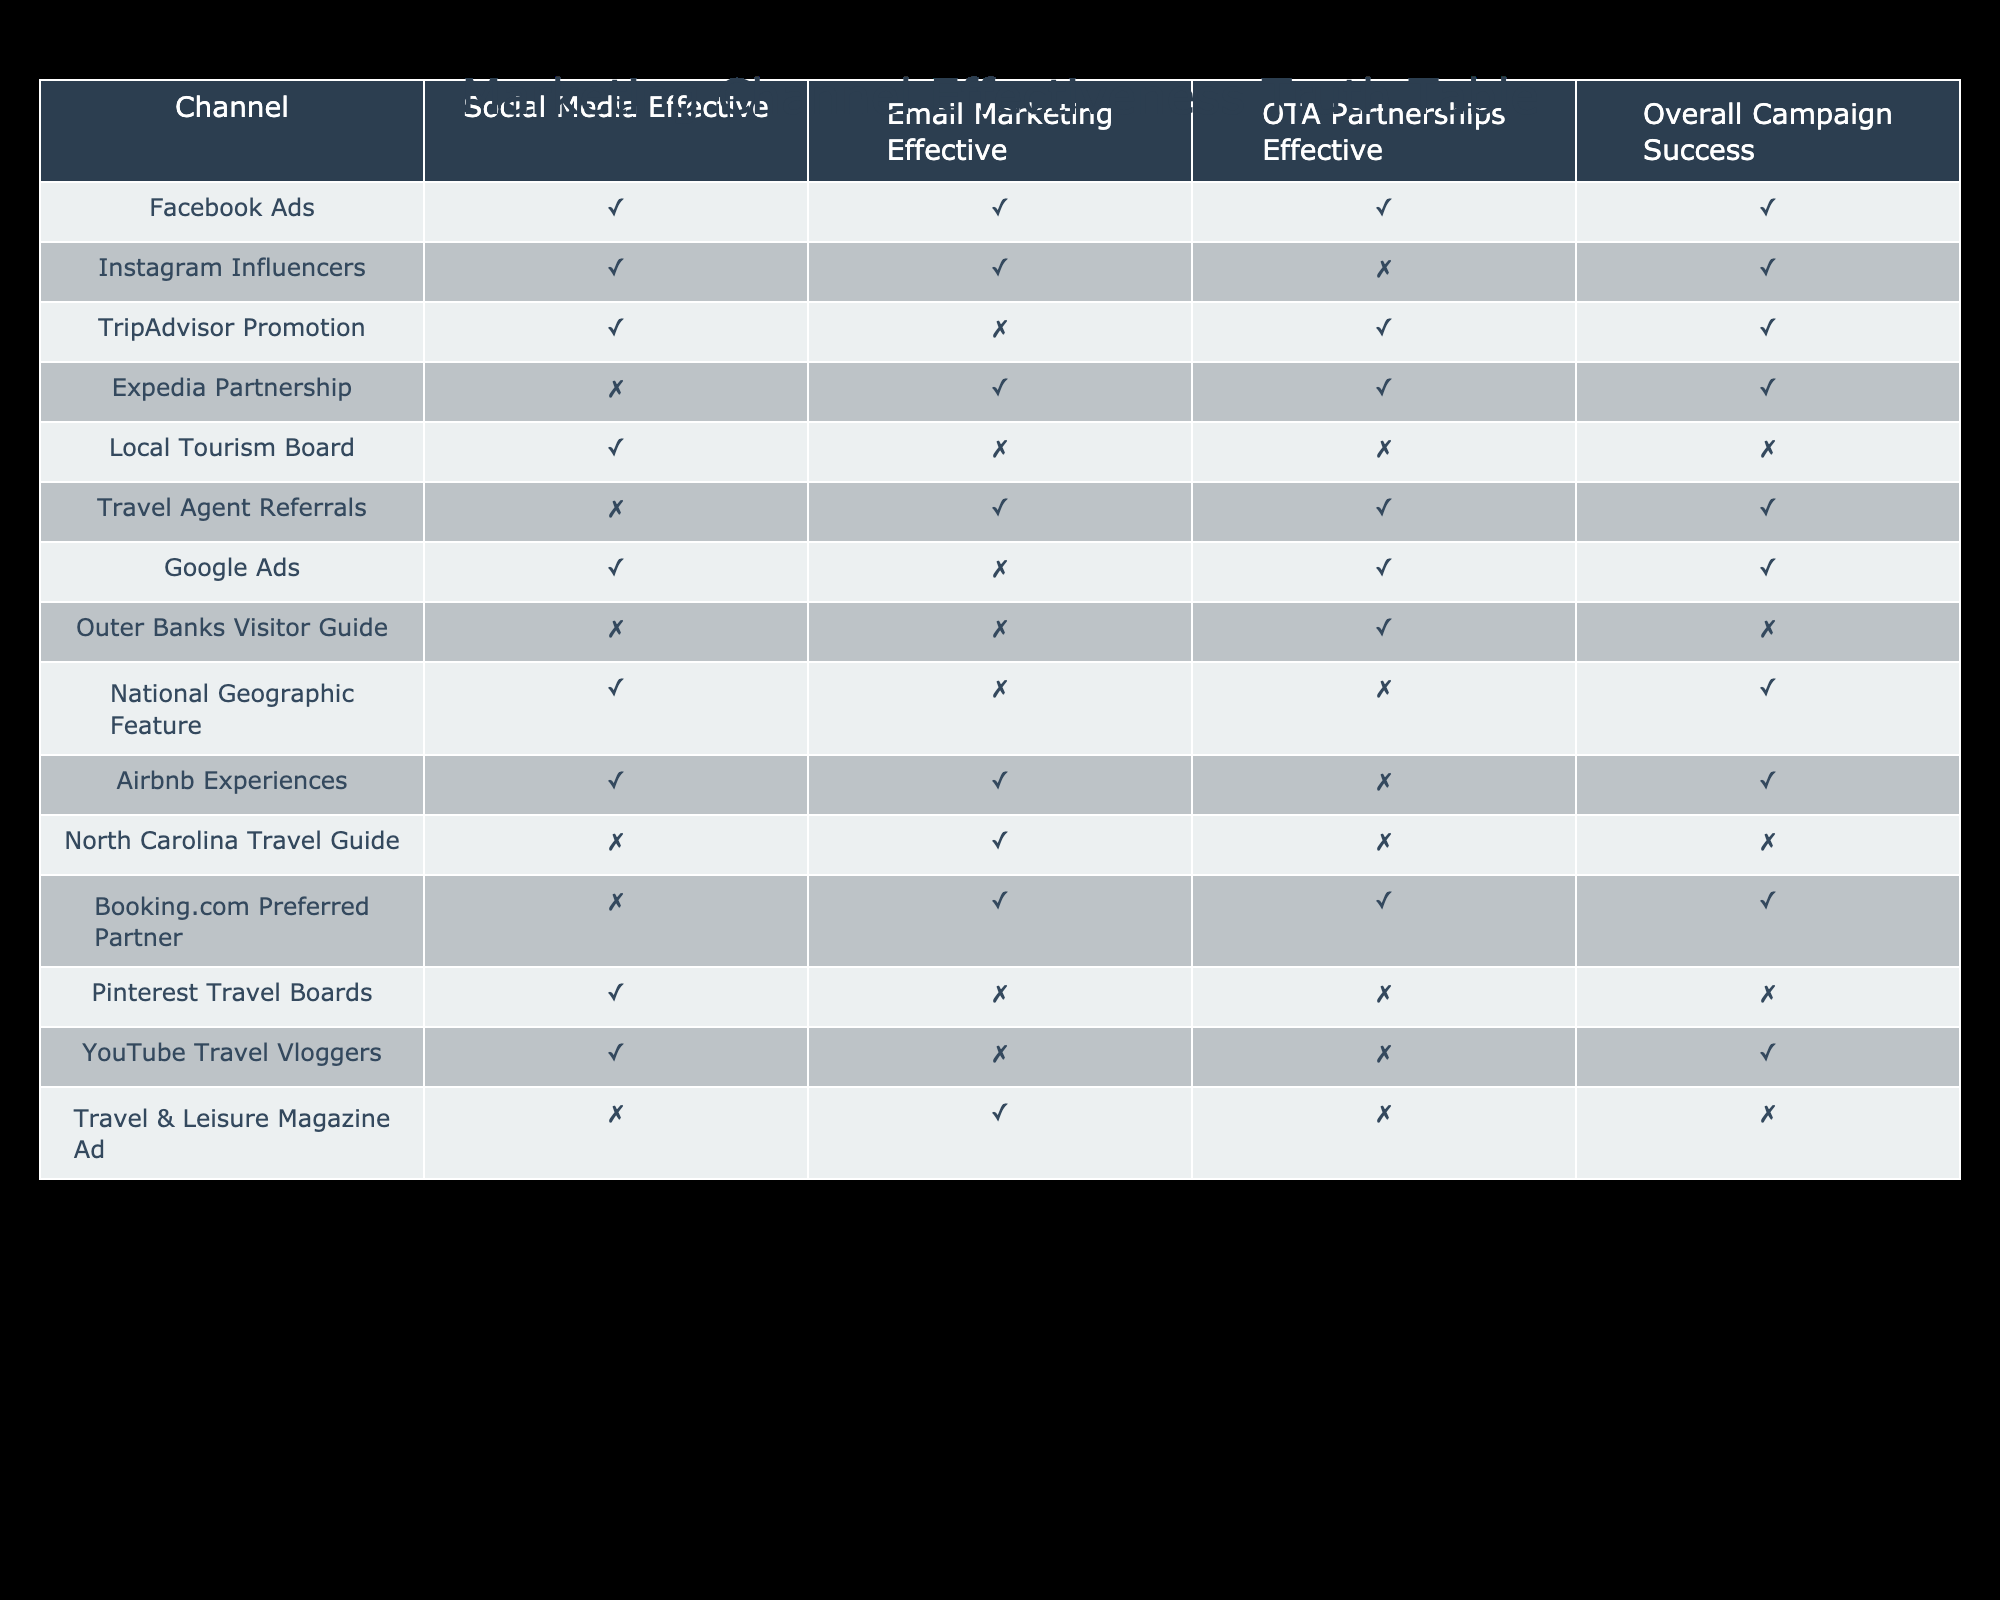What marketing channels were effective for the "TripAdvisor Promotion"? The table indicates that "TripAdvisor Promotion" was effective on "Social Media" and "OTA Partnerships," as both are marked TRUE. Therefore, the effective channels are those two.
Answer: Social Media, OTA Partnerships How many marketing channels are effective for "Email Marketing"? By reviewing the table, it's evident that the following channels are effective for Email Marketing: Instagram Influencers, Expedia Partnership, Travel Agent Referrals, and Booking.com Preferred Partner. There are four channels with TRUE for Email Marketing effectiveness.
Answer: 4 Is there a marketing channel that is effective for "Social Media" but not for "OTA Partnerships"? Looking at the table, "Local Tourism Board" is effective on Social Media (TRUE) and has no effectiveness on OTA Partnerships (FALSE). Therefore, it fits the criteria of being effective for Social Media but ineffective for OTA Partnerships.
Answer: Yes What is the overall success rate of campaigns that utilized both "Email Marketing" and "OTA Partnerships"? From the table, we identify the channels that were effective in both Email Marketing and OTA Partnerships: Expedia Partnership, Travel Agent Referrals, and Booking.com Preferred Partner. In total, there are three channels where both criteria are fulfilled, and all three channels also have an overall campaign success of TRUE. This results in a successful rate of 100% for these channels.
Answer: 100% Which marketing channels have "Social Media Effective" as TRUE and "Overall Campaign Success" as FALSE? In the table, the only channel that meets this criteria is "Local Tourism Board." This channel shows TRUE for Social Media effectiveness but FALSE for overall campaign success.
Answer: Local Tourism Board How many marketing channels were listed as ineffective for "Google Ads"? The table indicates that only one channel, "Outer Banks Visitor Guide," is written with FALSE for Google Ads. Thus, there is only one marketing channel specified as ineffective in that category.
Answer: 1 Are there any channels that were found effective across all categories? Based on the data, "Facebook Ads" stands out, as it has TRUE marked in all categories: Social Media Effective, Email Marketing Effective, and OTA Partnerships Effective, leading to a conclusion of being effective across the board.
Answer: Yes What’s the difference in the number of effective channels for "Social Media" compared to "Email Marketing"? To find the difference, we count the channels with TRUE under each category. For Social Media, there are 7 effective channels. For Email Marketing, there are 6 effective channels. The difference is 7 - 6 = 1.
Answer: 1 